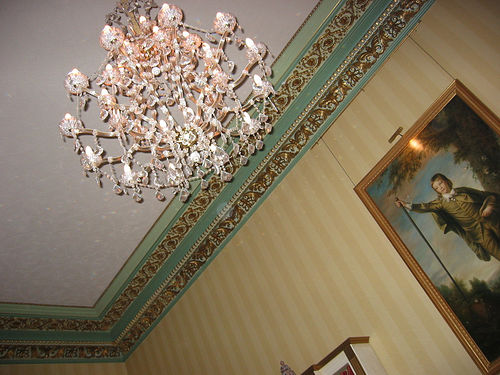<image>
Is there a ceiling above the chandelier? Yes. The ceiling is positioned above the chandelier in the vertical space, higher up in the scene. 